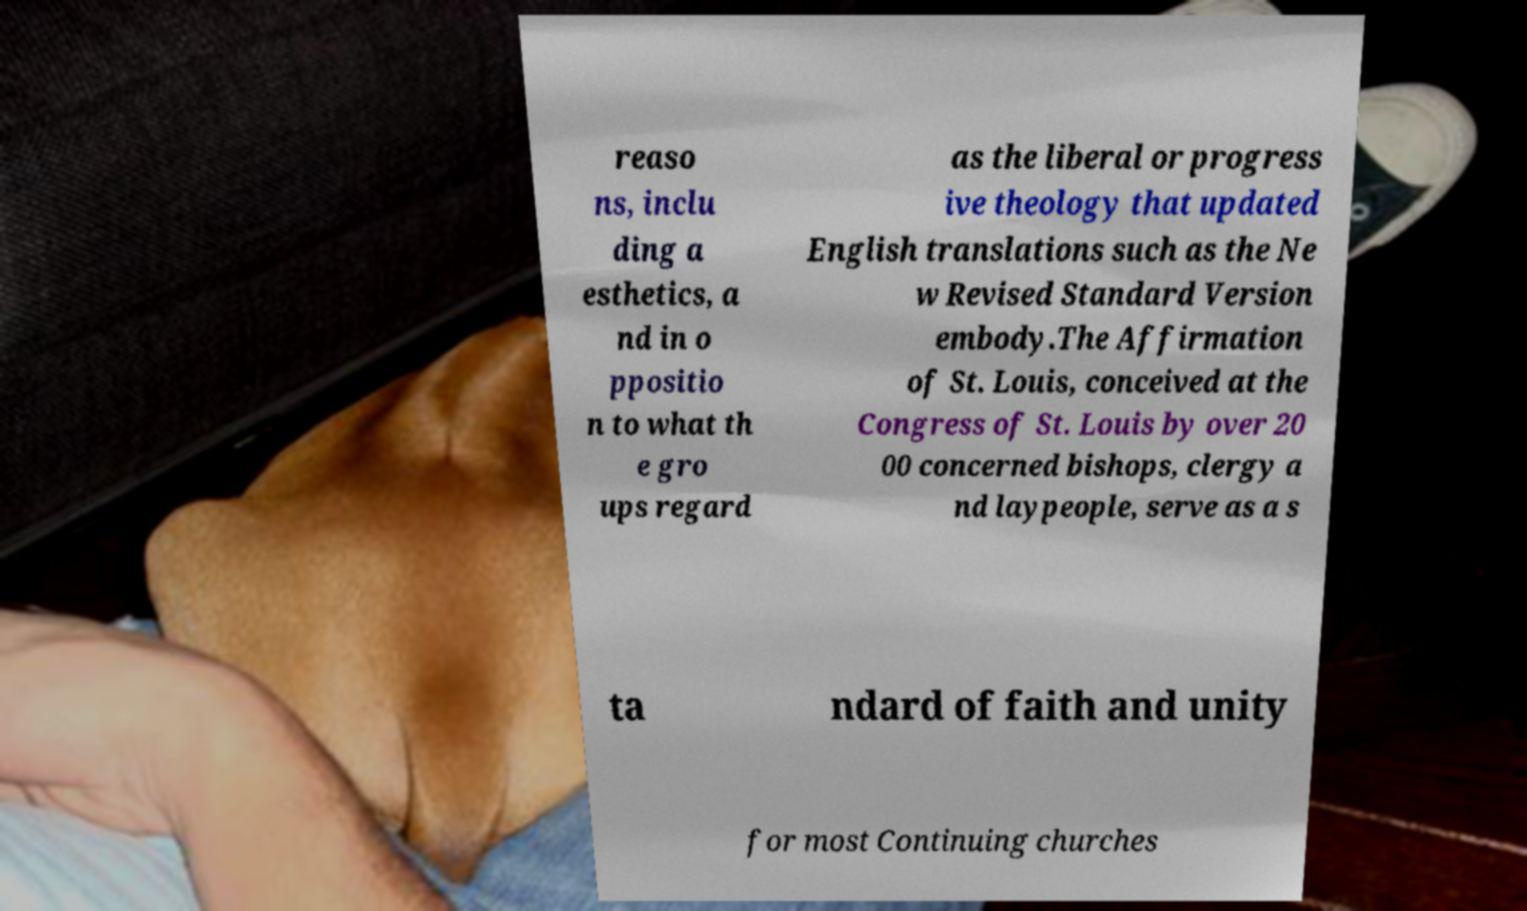Please read and relay the text visible in this image. What does it say? reaso ns, inclu ding a esthetics, a nd in o ppositio n to what th e gro ups regard as the liberal or progress ive theology that updated English translations such as the Ne w Revised Standard Version embody.The Affirmation of St. Louis, conceived at the Congress of St. Louis by over 20 00 concerned bishops, clergy a nd laypeople, serve as a s ta ndard of faith and unity for most Continuing churches 